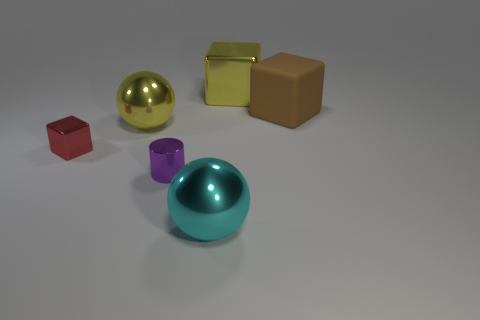Are there any other yellow metallic cubes of the same size as the yellow metallic cube?
Your answer should be very brief. No. What number of other cyan things are the same shape as the large matte object?
Give a very brief answer. 0. Is the number of small purple cylinders that are behind the tiny shiny cylinder the same as the number of big yellow cubes that are in front of the large yellow shiny sphere?
Offer a terse response. Yes. Are there any large green cylinders?
Your response must be concise. No. How big is the shiny block in front of the big brown rubber cube behind the purple cylinder behind the big cyan metallic ball?
Your response must be concise. Small. There is a cyan thing that is the same size as the brown cube; what is its shape?
Give a very brief answer. Sphere. Are there any other things that are made of the same material as the brown object?
Make the answer very short. No. What number of objects are either cubes that are in front of the big yellow cube or large green metallic things?
Keep it short and to the point. 2. There is a big rubber object that is behind the large metallic ball that is to the right of the purple metal object; are there any cyan shiny balls that are in front of it?
Your answer should be very brief. Yes. How many purple metal cylinders are there?
Your answer should be compact. 1. 